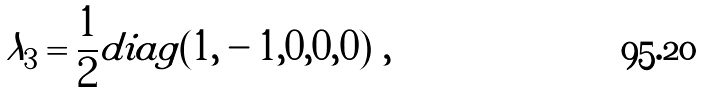<formula> <loc_0><loc_0><loc_500><loc_500>\lambda _ { 3 } = \frac { 1 } { 2 } d i a g ( 1 , - 1 , 0 , 0 , 0 ) \ ,</formula> 